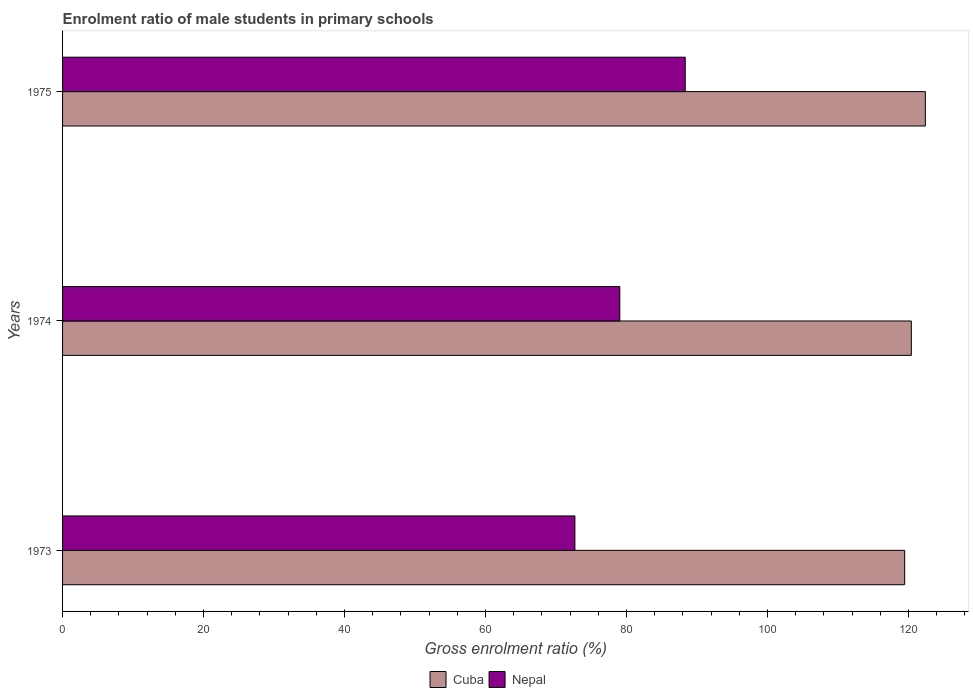How many different coloured bars are there?
Give a very brief answer. 2. Are the number of bars per tick equal to the number of legend labels?
Provide a succinct answer. Yes. Are the number of bars on each tick of the Y-axis equal?
Your answer should be very brief. Yes. How many bars are there on the 3rd tick from the top?
Provide a short and direct response. 2. What is the label of the 1st group of bars from the top?
Provide a succinct answer. 1975. In how many cases, is the number of bars for a given year not equal to the number of legend labels?
Your answer should be compact. 0. What is the enrolment ratio of male students in primary schools in Nepal in 1975?
Provide a succinct answer. 88.33. Across all years, what is the maximum enrolment ratio of male students in primary schools in Nepal?
Give a very brief answer. 88.33. Across all years, what is the minimum enrolment ratio of male students in primary schools in Cuba?
Your answer should be very brief. 119.45. In which year was the enrolment ratio of male students in primary schools in Nepal maximum?
Keep it short and to the point. 1975. In which year was the enrolment ratio of male students in primary schools in Cuba minimum?
Offer a terse response. 1973. What is the total enrolment ratio of male students in primary schools in Cuba in the graph?
Offer a very short reply. 362.24. What is the difference between the enrolment ratio of male students in primary schools in Nepal in 1973 and that in 1975?
Offer a terse response. -15.65. What is the difference between the enrolment ratio of male students in primary schools in Nepal in 1973 and the enrolment ratio of male students in primary schools in Cuba in 1975?
Your response must be concise. -49.71. What is the average enrolment ratio of male students in primary schools in Nepal per year?
Offer a terse response. 80.02. In the year 1973, what is the difference between the enrolment ratio of male students in primary schools in Cuba and enrolment ratio of male students in primary schools in Nepal?
Give a very brief answer. 46.77. What is the ratio of the enrolment ratio of male students in primary schools in Cuba in 1973 to that in 1974?
Provide a short and direct response. 0.99. Is the enrolment ratio of male students in primary schools in Cuba in 1973 less than that in 1975?
Your response must be concise. Yes. Is the difference between the enrolment ratio of male students in primary schools in Cuba in 1974 and 1975 greater than the difference between the enrolment ratio of male students in primary schools in Nepal in 1974 and 1975?
Your answer should be very brief. Yes. What is the difference between the highest and the second highest enrolment ratio of male students in primary schools in Cuba?
Offer a very short reply. 1.99. What is the difference between the highest and the lowest enrolment ratio of male students in primary schools in Nepal?
Your answer should be very brief. 15.65. In how many years, is the enrolment ratio of male students in primary schools in Cuba greater than the average enrolment ratio of male students in primary schools in Cuba taken over all years?
Provide a short and direct response. 1. Is the sum of the enrolment ratio of male students in primary schools in Cuba in 1973 and 1974 greater than the maximum enrolment ratio of male students in primary schools in Nepal across all years?
Give a very brief answer. Yes. What does the 2nd bar from the top in 1973 represents?
Make the answer very short. Cuba. What does the 2nd bar from the bottom in 1974 represents?
Your answer should be compact. Nepal. How many bars are there?
Offer a terse response. 6. What is the difference between two consecutive major ticks on the X-axis?
Offer a very short reply. 20. How many legend labels are there?
Your response must be concise. 2. How are the legend labels stacked?
Provide a short and direct response. Horizontal. What is the title of the graph?
Make the answer very short. Enrolment ratio of male students in primary schools. Does "European Union" appear as one of the legend labels in the graph?
Keep it short and to the point. No. What is the label or title of the X-axis?
Provide a succinct answer. Gross enrolment ratio (%). What is the label or title of the Y-axis?
Keep it short and to the point. Years. What is the Gross enrolment ratio (%) of Cuba in 1973?
Make the answer very short. 119.45. What is the Gross enrolment ratio (%) in Nepal in 1973?
Keep it short and to the point. 72.68. What is the Gross enrolment ratio (%) of Cuba in 1974?
Give a very brief answer. 120.4. What is the Gross enrolment ratio (%) of Nepal in 1974?
Provide a succinct answer. 79.04. What is the Gross enrolment ratio (%) of Cuba in 1975?
Make the answer very short. 122.39. What is the Gross enrolment ratio (%) in Nepal in 1975?
Offer a terse response. 88.33. Across all years, what is the maximum Gross enrolment ratio (%) of Cuba?
Make the answer very short. 122.39. Across all years, what is the maximum Gross enrolment ratio (%) of Nepal?
Provide a short and direct response. 88.33. Across all years, what is the minimum Gross enrolment ratio (%) of Cuba?
Your answer should be very brief. 119.45. Across all years, what is the minimum Gross enrolment ratio (%) of Nepal?
Provide a succinct answer. 72.68. What is the total Gross enrolment ratio (%) of Cuba in the graph?
Give a very brief answer. 362.24. What is the total Gross enrolment ratio (%) of Nepal in the graph?
Keep it short and to the point. 240.05. What is the difference between the Gross enrolment ratio (%) in Cuba in 1973 and that in 1974?
Your response must be concise. -0.95. What is the difference between the Gross enrolment ratio (%) of Nepal in 1973 and that in 1974?
Your answer should be very brief. -6.37. What is the difference between the Gross enrolment ratio (%) of Cuba in 1973 and that in 1975?
Your answer should be compact. -2.94. What is the difference between the Gross enrolment ratio (%) in Nepal in 1973 and that in 1975?
Ensure brevity in your answer.  -15.65. What is the difference between the Gross enrolment ratio (%) in Cuba in 1974 and that in 1975?
Offer a very short reply. -1.99. What is the difference between the Gross enrolment ratio (%) of Nepal in 1974 and that in 1975?
Keep it short and to the point. -9.28. What is the difference between the Gross enrolment ratio (%) in Cuba in 1973 and the Gross enrolment ratio (%) in Nepal in 1974?
Your response must be concise. 40.41. What is the difference between the Gross enrolment ratio (%) of Cuba in 1973 and the Gross enrolment ratio (%) of Nepal in 1975?
Provide a short and direct response. 31.12. What is the difference between the Gross enrolment ratio (%) in Cuba in 1974 and the Gross enrolment ratio (%) in Nepal in 1975?
Provide a short and direct response. 32.07. What is the average Gross enrolment ratio (%) of Cuba per year?
Provide a succinct answer. 120.75. What is the average Gross enrolment ratio (%) of Nepal per year?
Provide a short and direct response. 80.02. In the year 1973, what is the difference between the Gross enrolment ratio (%) of Cuba and Gross enrolment ratio (%) of Nepal?
Provide a short and direct response. 46.77. In the year 1974, what is the difference between the Gross enrolment ratio (%) in Cuba and Gross enrolment ratio (%) in Nepal?
Keep it short and to the point. 41.36. In the year 1975, what is the difference between the Gross enrolment ratio (%) of Cuba and Gross enrolment ratio (%) of Nepal?
Your answer should be compact. 34.06. What is the ratio of the Gross enrolment ratio (%) in Cuba in 1973 to that in 1974?
Keep it short and to the point. 0.99. What is the ratio of the Gross enrolment ratio (%) in Nepal in 1973 to that in 1974?
Your answer should be compact. 0.92. What is the ratio of the Gross enrolment ratio (%) in Cuba in 1973 to that in 1975?
Your answer should be compact. 0.98. What is the ratio of the Gross enrolment ratio (%) of Nepal in 1973 to that in 1975?
Provide a succinct answer. 0.82. What is the ratio of the Gross enrolment ratio (%) of Cuba in 1974 to that in 1975?
Your answer should be compact. 0.98. What is the ratio of the Gross enrolment ratio (%) in Nepal in 1974 to that in 1975?
Make the answer very short. 0.89. What is the difference between the highest and the second highest Gross enrolment ratio (%) of Cuba?
Your answer should be compact. 1.99. What is the difference between the highest and the second highest Gross enrolment ratio (%) of Nepal?
Your answer should be very brief. 9.28. What is the difference between the highest and the lowest Gross enrolment ratio (%) of Cuba?
Give a very brief answer. 2.94. What is the difference between the highest and the lowest Gross enrolment ratio (%) in Nepal?
Offer a terse response. 15.65. 